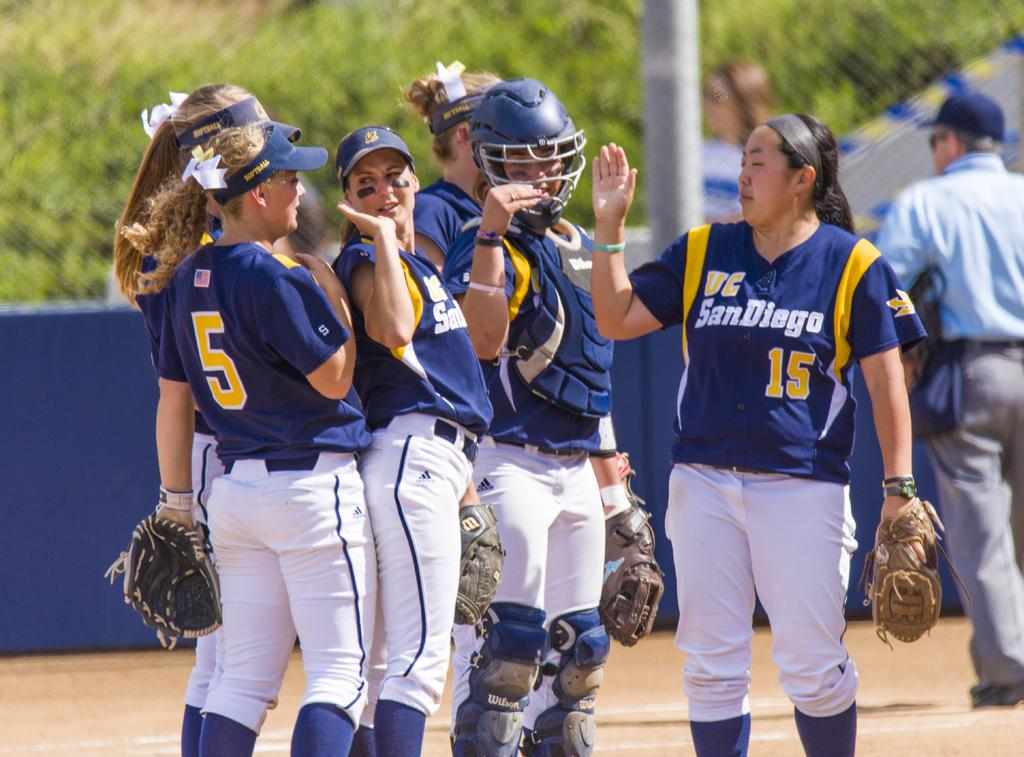<image>
Summarize the visual content of the image. a team with the name San Diego on their jerseys 